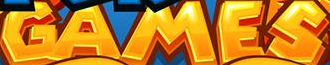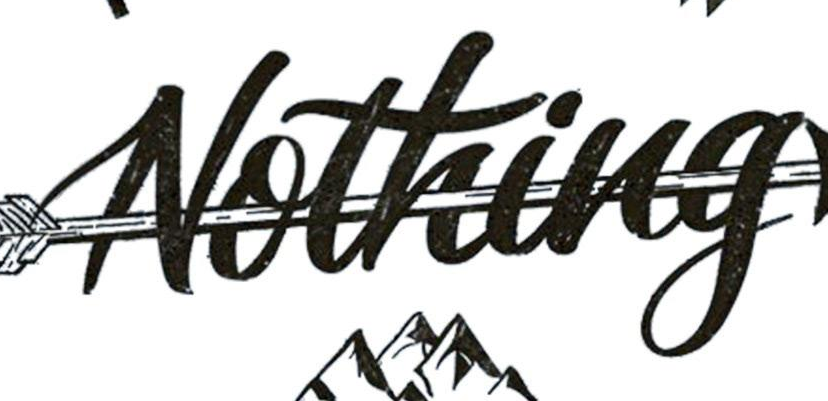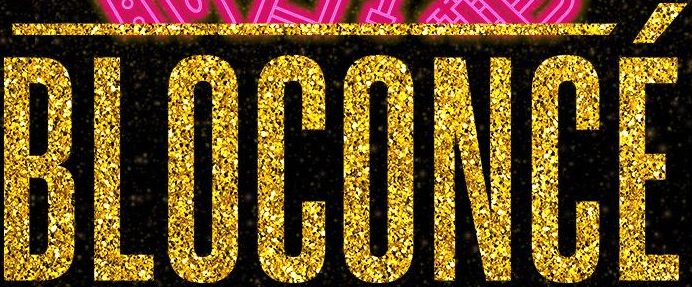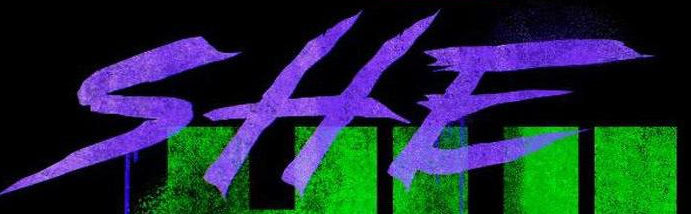What words can you see in these images in sequence, separated by a semicolon? GAMES; Nothing; BLOCONCÉ; SHE 